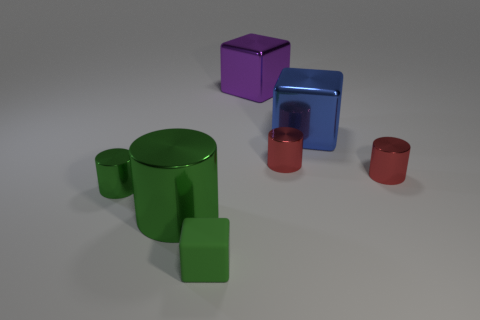Subtract all big cylinders. How many cylinders are left? 3 Add 3 large blue rubber cylinders. How many objects exist? 10 Subtract all cubes. How many objects are left? 4 Add 1 small green metal cylinders. How many small green metal cylinders exist? 2 Subtract all red cylinders. How many cylinders are left? 2 Subtract 0 brown cylinders. How many objects are left? 7 Subtract 1 cubes. How many cubes are left? 2 Subtract all purple blocks. Subtract all blue balls. How many blocks are left? 2 Subtract all gray blocks. How many red cylinders are left? 2 Subtract all big green spheres. Subtract all purple objects. How many objects are left? 6 